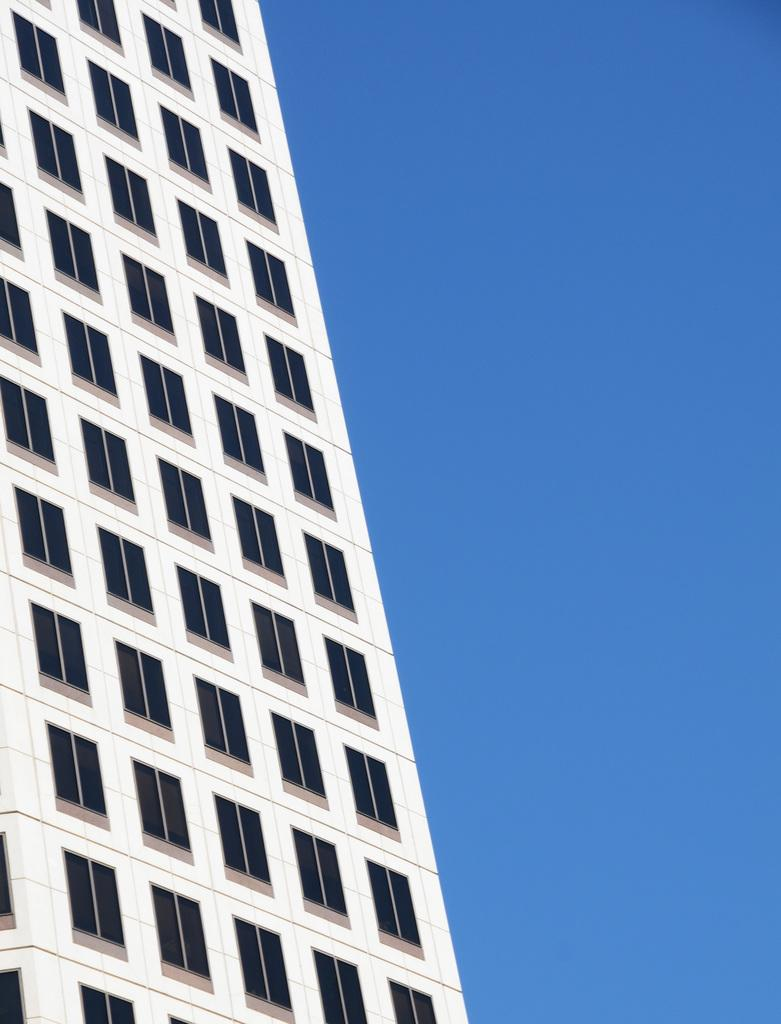What structure is located on the left side of the image? There is a building on the left side of the image. What is the color of the building? The building is white in color. How many windows can be seen on the building? The building has many windows. What is visible on the right side of the image? The sky is visible on the right side of the image. What is the color of the sky? The sky is blue in color. Can you tell me how many owls are sitting on the building in the image? There are no owls present in the image; it only features a white building with many windows and a blue sky. 